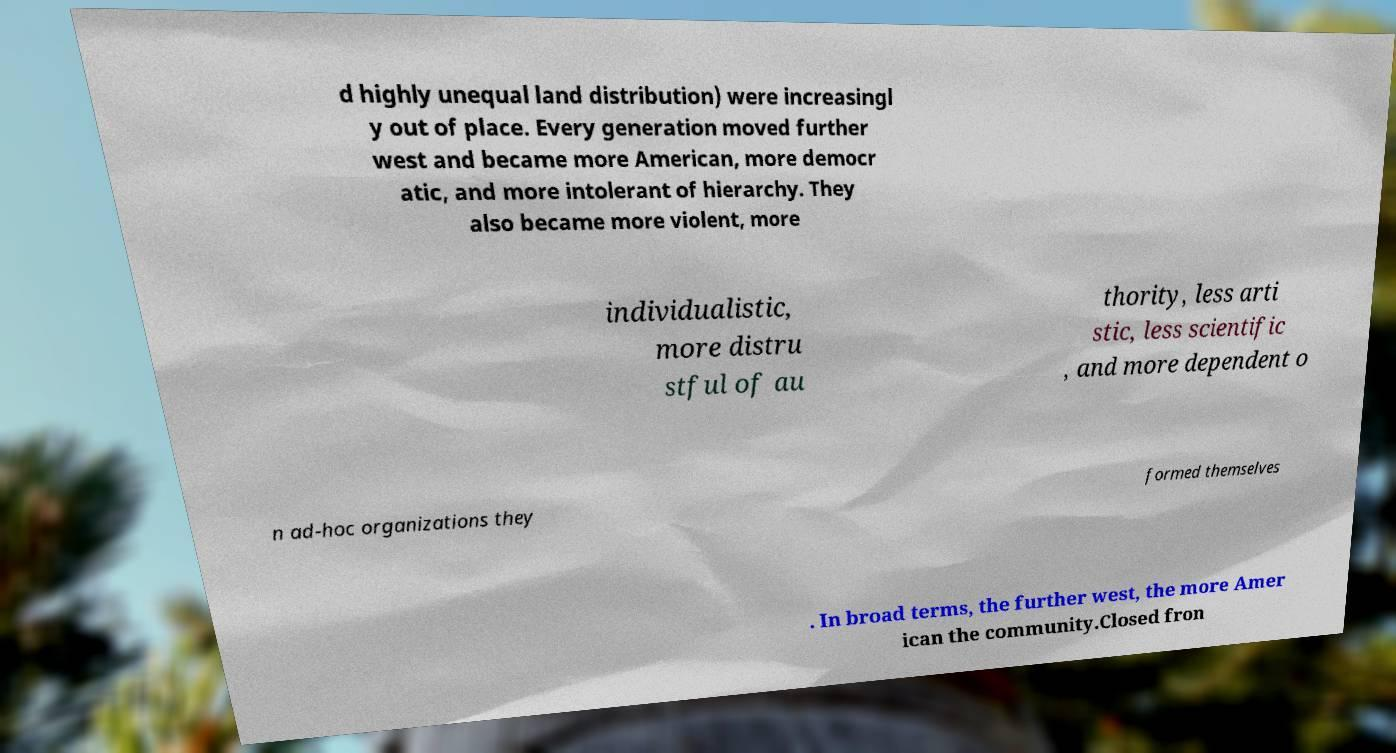Could you extract and type out the text from this image? d highly unequal land distribution) were increasingl y out of place. Every generation moved further west and became more American, more democr atic, and more intolerant of hierarchy. They also became more violent, more individualistic, more distru stful of au thority, less arti stic, less scientific , and more dependent o n ad-hoc organizations they formed themselves . In broad terms, the further west, the more Amer ican the community.Closed fron 